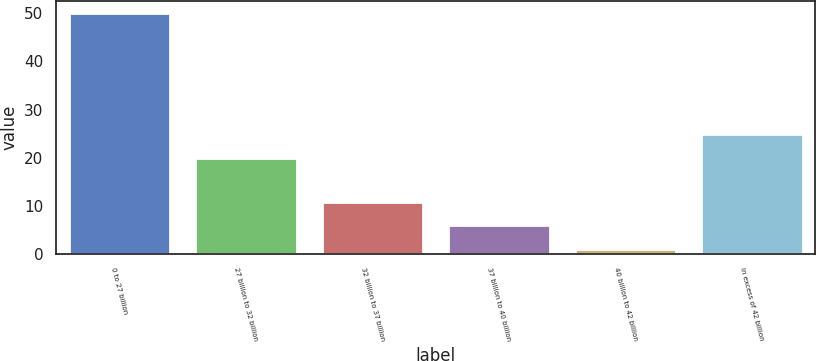Convert chart to OTSL. <chart><loc_0><loc_0><loc_500><loc_500><bar_chart><fcel>0 to 27 billion<fcel>27 billion to 32 billion<fcel>32 billion to 37 billion<fcel>37 billion to 40 billion<fcel>40 billion to 42 billion<fcel>In excess of 42 billion<nl><fcel>50<fcel>20<fcel>10.8<fcel>5.9<fcel>1<fcel>24.9<nl></chart> 